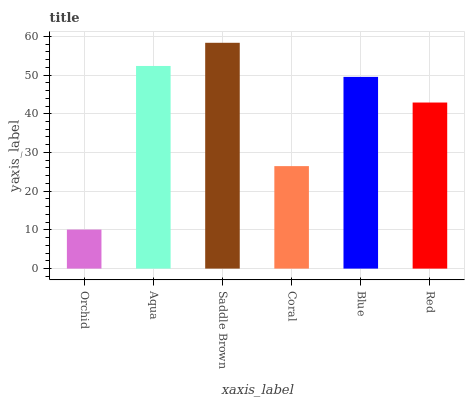Is Orchid the minimum?
Answer yes or no. Yes. Is Saddle Brown the maximum?
Answer yes or no. Yes. Is Aqua the minimum?
Answer yes or no. No. Is Aqua the maximum?
Answer yes or no. No. Is Aqua greater than Orchid?
Answer yes or no. Yes. Is Orchid less than Aqua?
Answer yes or no. Yes. Is Orchid greater than Aqua?
Answer yes or no. No. Is Aqua less than Orchid?
Answer yes or no. No. Is Blue the high median?
Answer yes or no. Yes. Is Red the low median?
Answer yes or no. Yes. Is Red the high median?
Answer yes or no. No. Is Orchid the low median?
Answer yes or no. No. 